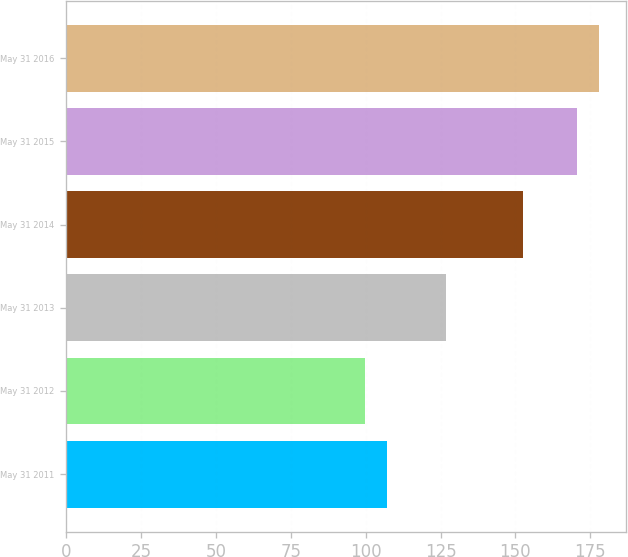Convert chart. <chart><loc_0><loc_0><loc_500><loc_500><bar_chart><fcel>May 31 2011<fcel>May 31 2012<fcel>May 31 2013<fcel>May 31 2014<fcel>May 31 2015<fcel>May 31 2016<nl><fcel>106.99<fcel>99.59<fcel>126.75<fcel>152.67<fcel>170.69<fcel>178.09<nl></chart> 